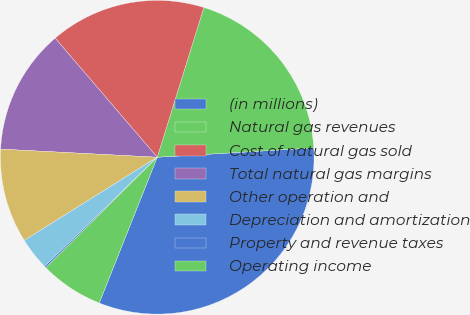Convert chart. <chart><loc_0><loc_0><loc_500><loc_500><pie_chart><fcel>(in millions)<fcel>Natural gas revenues<fcel>Cost of natural gas sold<fcel>Total natural gas margins<fcel>Other operation and<fcel>Depreciation and amortization<fcel>Property and revenue taxes<fcel>Operating income<nl><fcel>31.97%<fcel>19.25%<fcel>16.08%<fcel>12.9%<fcel>9.72%<fcel>3.36%<fcel>0.18%<fcel>6.54%<nl></chart> 